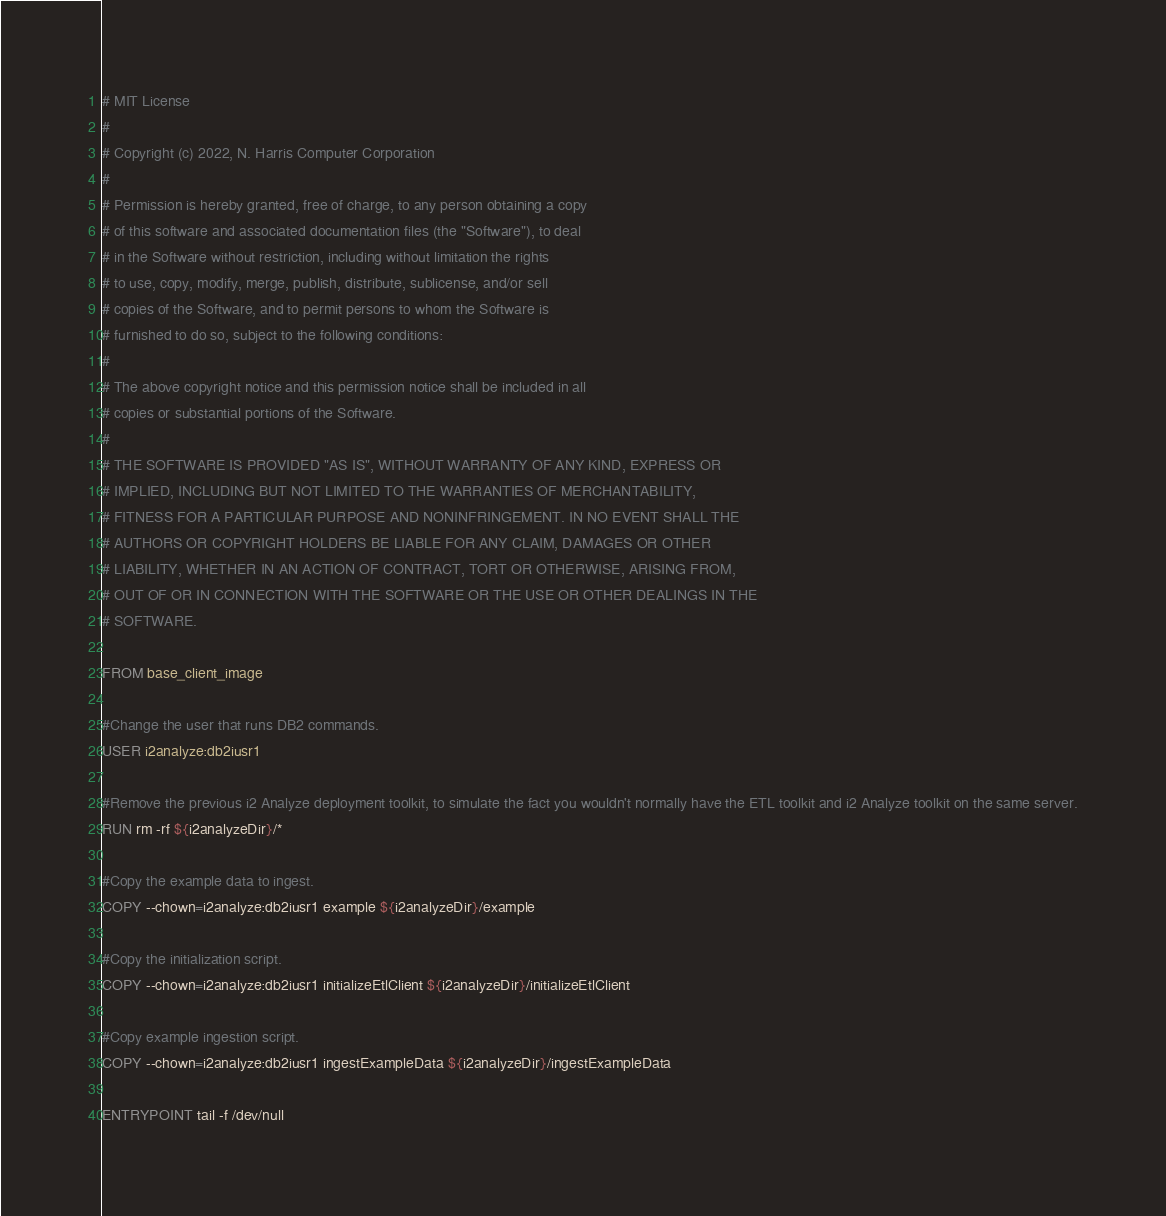Convert code to text. <code><loc_0><loc_0><loc_500><loc_500><_Dockerfile_># MIT License
#
# Copyright (c) 2022, N. Harris Computer Corporation
#
# Permission is hereby granted, free of charge, to any person obtaining a copy
# of this software and associated documentation files (the "Software"), to deal
# in the Software without restriction, including without limitation the rights
# to use, copy, modify, merge, publish, distribute, sublicense, and/or sell
# copies of the Software, and to permit persons to whom the Software is
# furnished to do so, subject to the following conditions:
#
# The above copyright notice and this permission notice shall be included in all
# copies or substantial portions of the Software.
#
# THE SOFTWARE IS PROVIDED "AS IS", WITHOUT WARRANTY OF ANY KIND, EXPRESS OR
# IMPLIED, INCLUDING BUT NOT LIMITED TO THE WARRANTIES OF MERCHANTABILITY,
# FITNESS FOR A PARTICULAR PURPOSE AND NONINFRINGEMENT. IN NO EVENT SHALL THE
# AUTHORS OR COPYRIGHT HOLDERS BE LIABLE FOR ANY CLAIM, DAMAGES OR OTHER
# LIABILITY, WHETHER IN AN ACTION OF CONTRACT, TORT OR OTHERWISE, ARISING FROM,
# OUT OF OR IN CONNECTION WITH THE SOFTWARE OR THE USE OR OTHER DEALINGS IN THE
# SOFTWARE.

FROM base_client_image

#Change the user that runs DB2 commands.
USER i2analyze:db2iusr1

#Remove the previous i2 Analyze deployment toolkit, to simulate the fact you wouldn't normally have the ETL toolkit and i2 Analyze toolkit on the same server.
RUN rm -rf ${i2analyzeDir}/*

#Copy the example data to ingest.
COPY --chown=i2analyze:db2iusr1 example ${i2analyzeDir}/example

#Copy the initialization script.
COPY --chown=i2analyze:db2iusr1 initializeEtlClient ${i2analyzeDir}/initializeEtlClient

#Copy example ingestion script.
COPY --chown=i2analyze:db2iusr1 ingestExampleData ${i2analyzeDir}/ingestExampleData

ENTRYPOINT tail -f /dev/null
</code> 